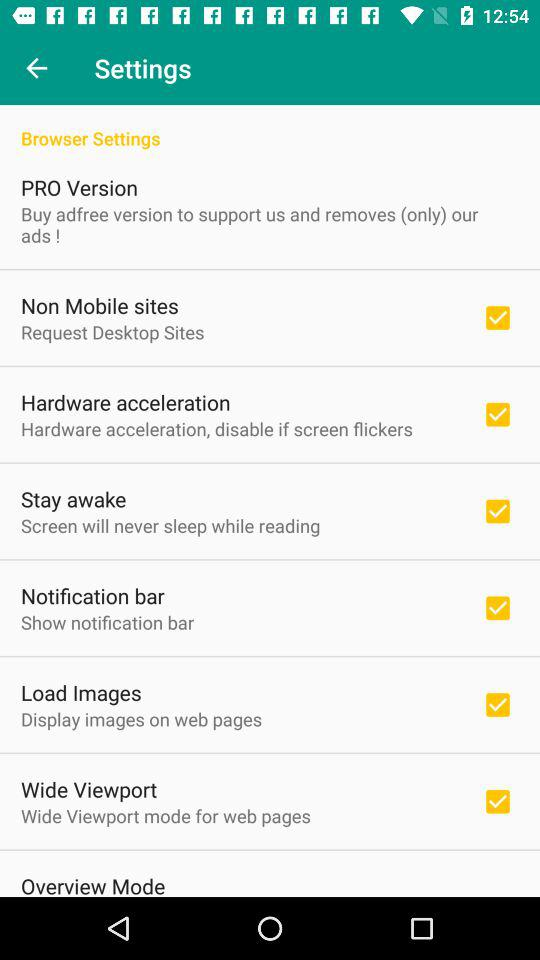What is the status of the load images setting option? The status of the load images is on. 